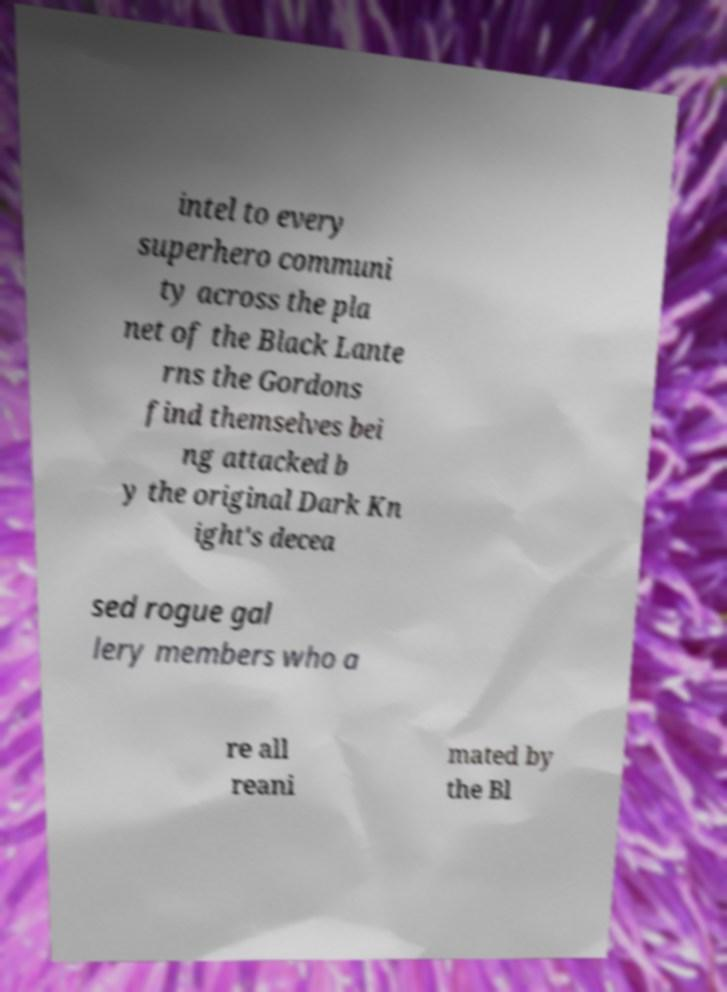Can you accurately transcribe the text from the provided image for me? intel to every superhero communi ty across the pla net of the Black Lante rns the Gordons find themselves bei ng attacked b y the original Dark Kn ight's decea sed rogue gal lery members who a re all reani mated by the Bl 